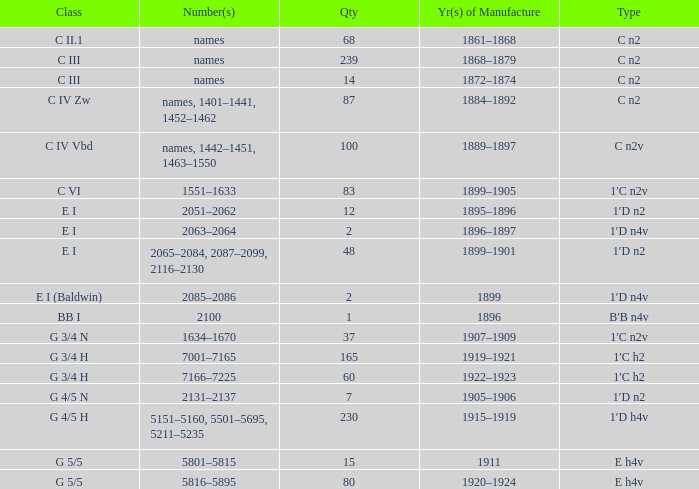Which Year(s) of Manufacture has a Quantity larger than 60, and a Number(s) of 7001–7165? 1919–1921. 